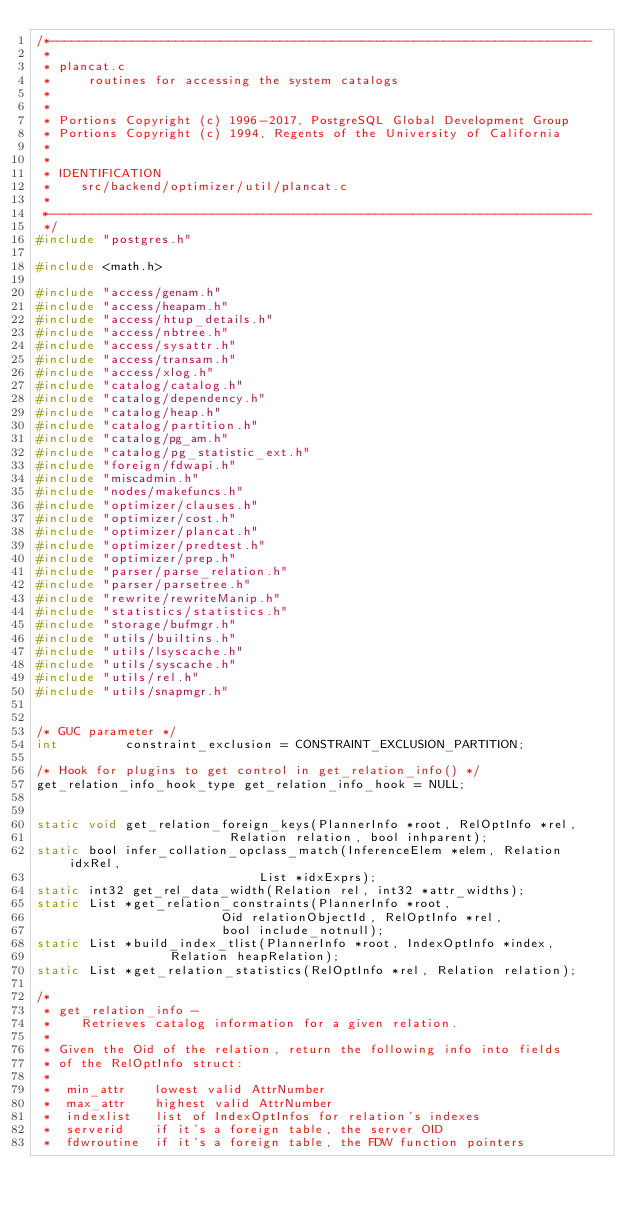<code> <loc_0><loc_0><loc_500><loc_500><_C_>/*-------------------------------------------------------------------------
 *
 * plancat.c
 *	   routines for accessing the system catalogs
 *
 *
 * Portions Copyright (c) 1996-2017, PostgreSQL Global Development Group
 * Portions Copyright (c) 1994, Regents of the University of California
 *
 *
 * IDENTIFICATION
 *	  src/backend/optimizer/util/plancat.c
 *
 *-------------------------------------------------------------------------
 */
#include "postgres.h"

#include <math.h>

#include "access/genam.h"
#include "access/heapam.h"
#include "access/htup_details.h"
#include "access/nbtree.h"
#include "access/sysattr.h"
#include "access/transam.h"
#include "access/xlog.h"
#include "catalog/catalog.h"
#include "catalog/dependency.h"
#include "catalog/heap.h"
#include "catalog/partition.h"
#include "catalog/pg_am.h"
#include "catalog/pg_statistic_ext.h"
#include "foreign/fdwapi.h"
#include "miscadmin.h"
#include "nodes/makefuncs.h"
#include "optimizer/clauses.h"
#include "optimizer/cost.h"
#include "optimizer/plancat.h"
#include "optimizer/predtest.h"
#include "optimizer/prep.h"
#include "parser/parse_relation.h"
#include "parser/parsetree.h"
#include "rewrite/rewriteManip.h"
#include "statistics/statistics.h"
#include "storage/bufmgr.h"
#include "utils/builtins.h"
#include "utils/lsyscache.h"
#include "utils/syscache.h"
#include "utils/rel.h"
#include "utils/snapmgr.h"


/* GUC parameter */
int			constraint_exclusion = CONSTRAINT_EXCLUSION_PARTITION;

/* Hook for plugins to get control in get_relation_info() */
get_relation_info_hook_type get_relation_info_hook = NULL;


static void get_relation_foreign_keys(PlannerInfo *root, RelOptInfo *rel,
						  Relation relation, bool inhparent);
static bool infer_collation_opclass_match(InferenceElem *elem, Relation idxRel,
							  List *idxExprs);
static int32 get_rel_data_width(Relation rel, int32 *attr_widths);
static List *get_relation_constraints(PlannerInfo *root,
						 Oid relationObjectId, RelOptInfo *rel,
						 bool include_notnull);
static List *build_index_tlist(PlannerInfo *root, IndexOptInfo *index,
				  Relation heapRelation);
static List *get_relation_statistics(RelOptInfo *rel, Relation relation);

/*
 * get_relation_info -
 *	  Retrieves catalog information for a given relation.
 *
 * Given the Oid of the relation, return the following info into fields
 * of the RelOptInfo struct:
 *
 *	min_attr	lowest valid AttrNumber
 *	max_attr	highest valid AttrNumber
 *	indexlist	list of IndexOptInfos for relation's indexes
 *	serverid	if it's a foreign table, the server OID
 *	fdwroutine	if it's a foreign table, the FDW function pointers</code> 